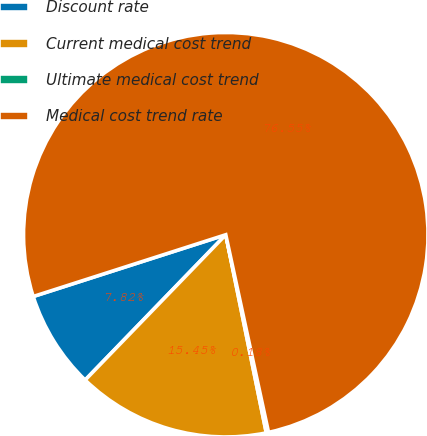Convert chart. <chart><loc_0><loc_0><loc_500><loc_500><pie_chart><fcel>Discount rate<fcel>Current medical cost trend<fcel>Ultimate medical cost trend<fcel>Medical cost trend rate<nl><fcel>7.82%<fcel>15.45%<fcel>0.18%<fcel>76.55%<nl></chart> 